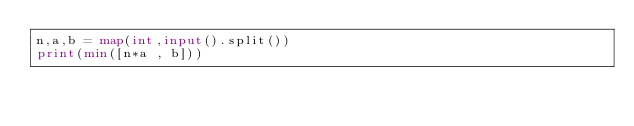<code> <loc_0><loc_0><loc_500><loc_500><_Python_>n,a,b = map(int,input().split())
print(min([n*a , b]))</code> 